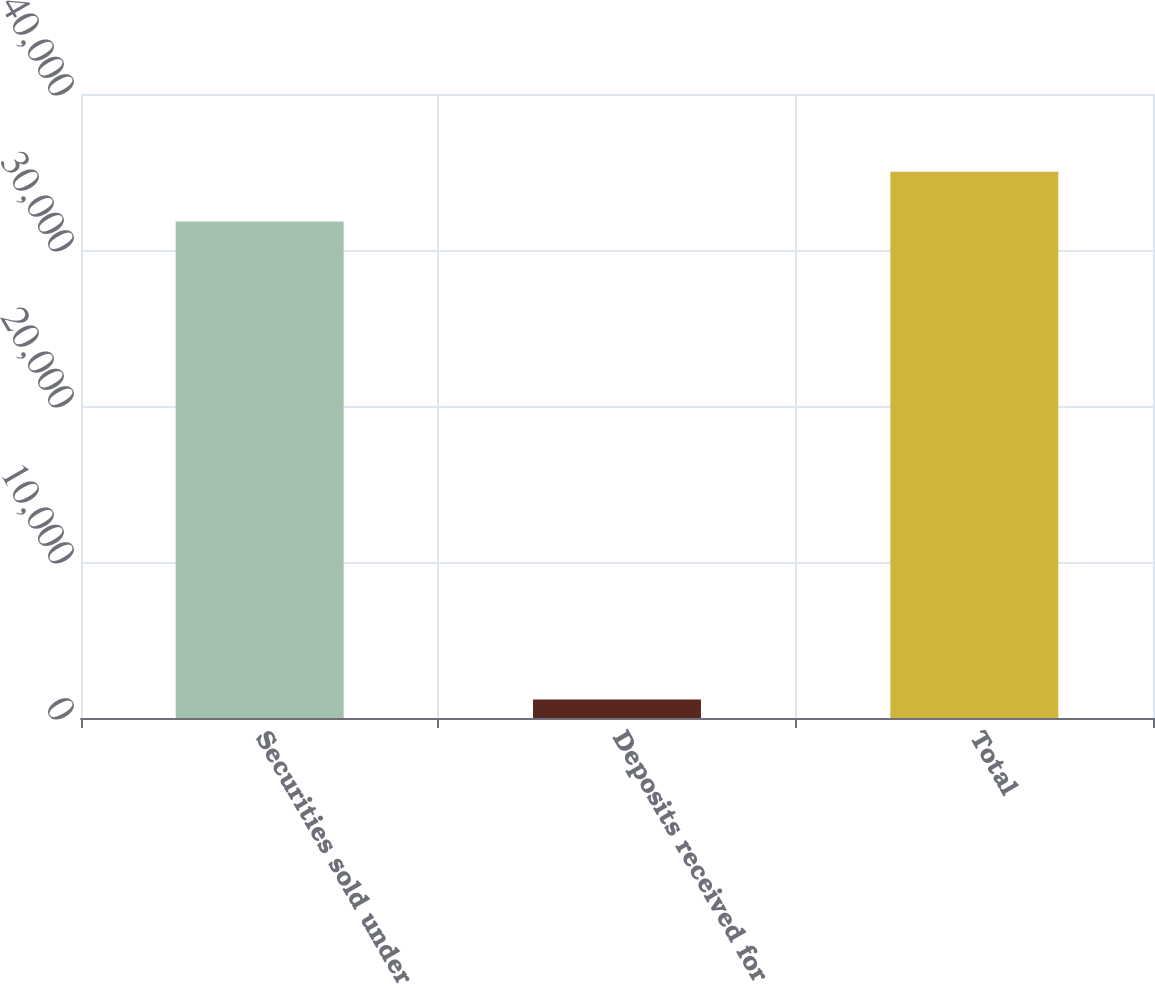Convert chart to OTSL. <chart><loc_0><loc_0><loc_500><loc_500><bar_chart><fcel>Securities sold under<fcel>Deposits received for<fcel>Total<nl><fcel>31831<fcel>1181<fcel>35014.1<nl></chart> 